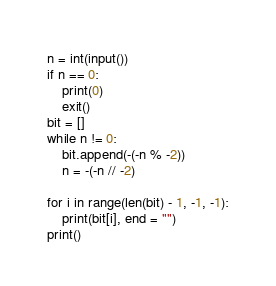Convert code to text. <code><loc_0><loc_0><loc_500><loc_500><_Python_>
n = int(input())
if n == 0:
    print(0)
    exit()
bit = []
while n != 0:
    bit.append(-(-n % -2))
    n = -(-n // -2)

for i in range(len(bit) - 1, -1, -1):
    print(bit[i], end = "")
print()</code> 